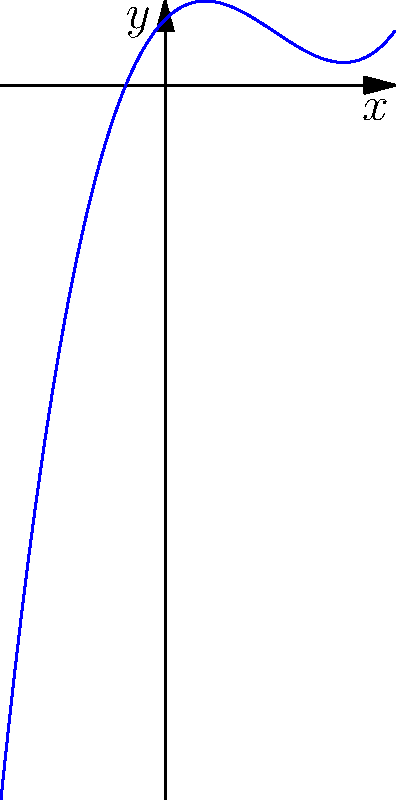As a competitive point guard, you know the importance of analyzing your opponent's plays. Similarly, in mathematics, analyzing a polynomial's behavior is crucial. Examine the graph above, which represents a polynomial function. Based on the end behavior of this graph as $x$ approaches positive and negative infinity, what is the degree of this polynomial? To determine the degree of a polynomial based on its end behavior, we need to follow these steps:

1) Observe the behavior of the graph as $x$ approaches positive infinity:
   The graph rises steeply upward, indicating a positive leading coefficient.

2) Observe the behavior of the graph as $x$ approaches negative infinity:
   The graph descends steeply downward.

3) The fact that one end goes up and the other goes down indicates an odd degree polynomial.

4) The steepness of the rise and fall suggests a degree higher than 1 (which would be a straight line).

5) The graph has two turning points (changes in direction), which is consistent with a cubic (3rd degree) polynomial.

6) For a cubic polynomial:
   - If the leading coefficient is positive, as $x \to \infty$, $y \to \infty$, and as $x \to -\infty$, $y \to -\infty$
   - This matches the behavior we see in the graph

Therefore, based on the end behavior and the overall shape of the graph, we can conclude that this is a 3rd degree (cubic) polynomial.
Answer: 3 